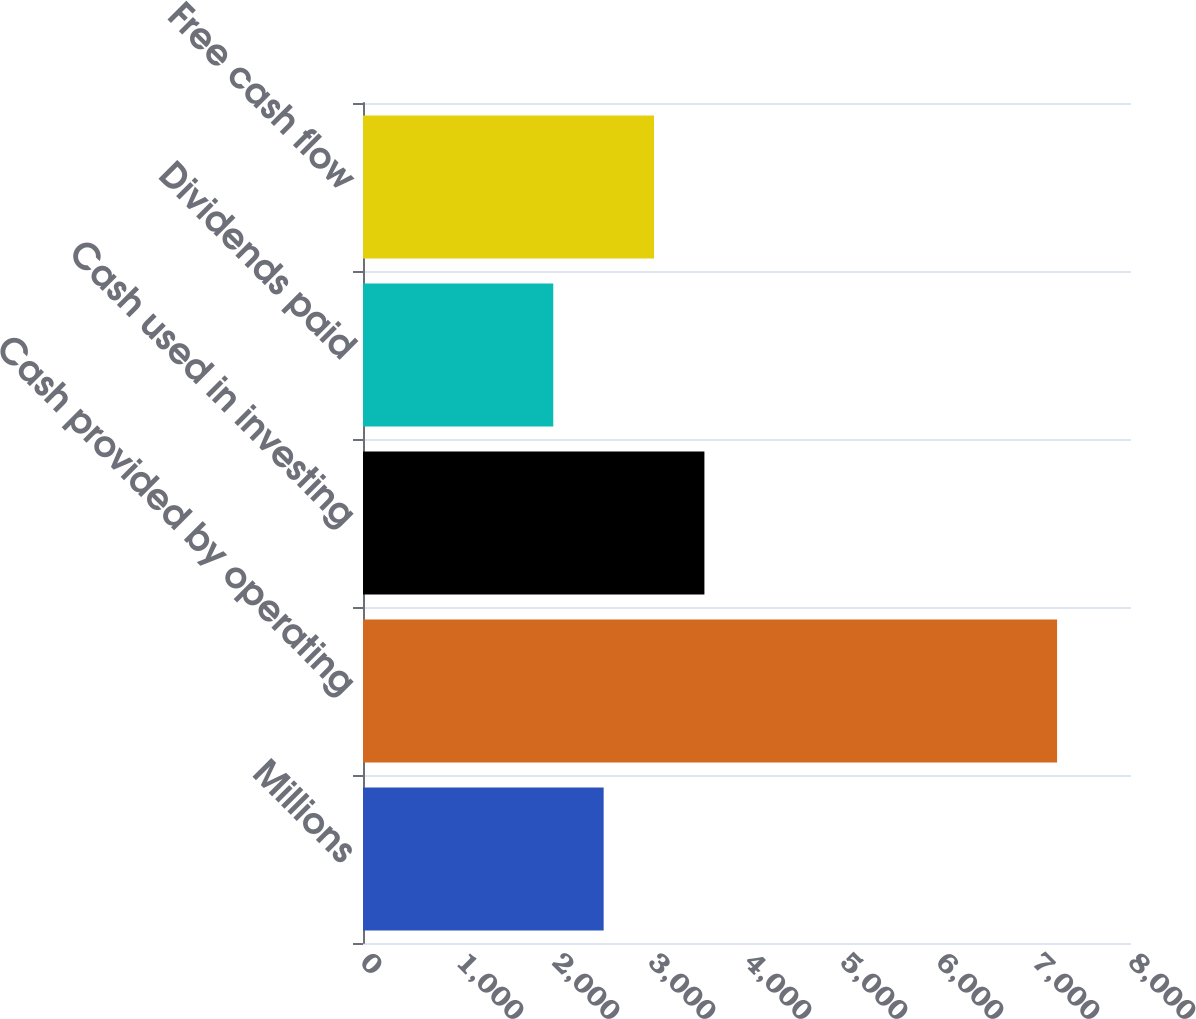<chart> <loc_0><loc_0><loc_500><loc_500><bar_chart><fcel>Millions<fcel>Cash provided by operating<fcel>Cash used in investing<fcel>Dividends paid<fcel>Free cash flow<nl><fcel>2506.8<fcel>7230<fcel>3556.4<fcel>1982<fcel>3031.6<nl></chart> 